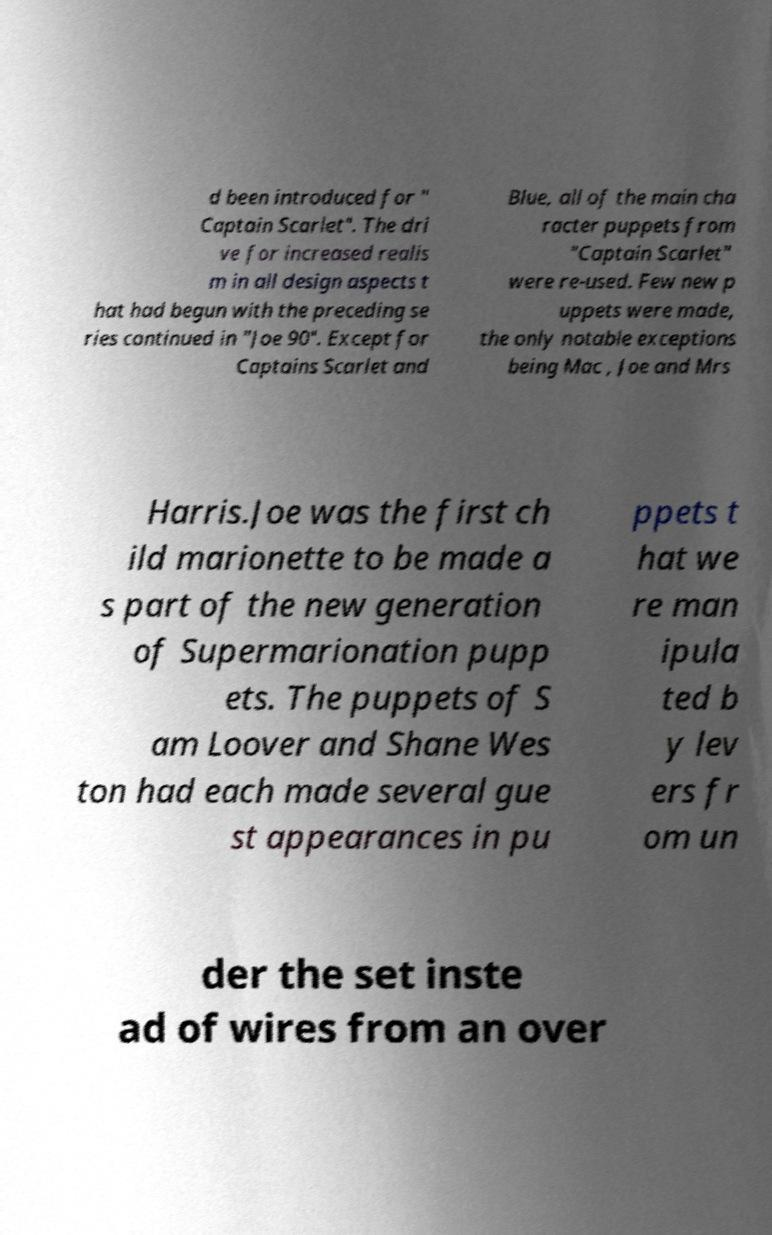Can you accurately transcribe the text from the provided image for me? d been introduced for " Captain Scarlet". The dri ve for increased realis m in all design aspects t hat had begun with the preceding se ries continued in "Joe 90". Except for Captains Scarlet and Blue, all of the main cha racter puppets from "Captain Scarlet" were re-used. Few new p uppets were made, the only notable exceptions being Mac , Joe and Mrs Harris.Joe was the first ch ild marionette to be made a s part of the new generation of Supermarionation pupp ets. The puppets of S am Loover and Shane Wes ton had each made several gue st appearances in pu ppets t hat we re man ipula ted b y lev ers fr om un der the set inste ad of wires from an over 